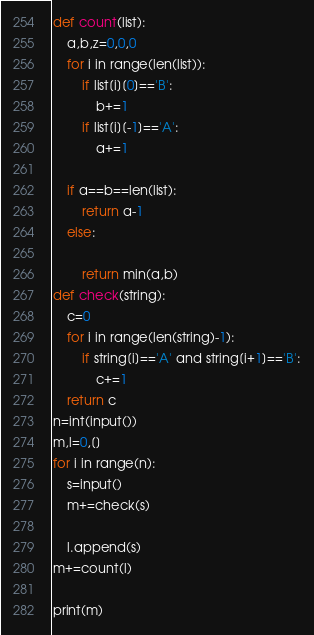Convert code to text. <code><loc_0><loc_0><loc_500><loc_500><_Python_>def count(list):
    a,b,z=0,0,0
    for i in range(len(list)):
        if list[i][0]=='B':
            b+=1
        if list[i][-1]=='A':
            a+=1
        
    if a==b==len(list):
        return a-1
    else:
        
        return min(a,b)
def check(string):
    c=0
    for i in range(len(string)-1):
        if string[i]=='A' and string[i+1]=='B':
            c+=1
    return c
n=int(input())
m,l=0,[]
for i in range(n):
    s=input()
    m+=check(s)
    
    l.append(s)
m+=count(l)
 
print(m)
</code> 